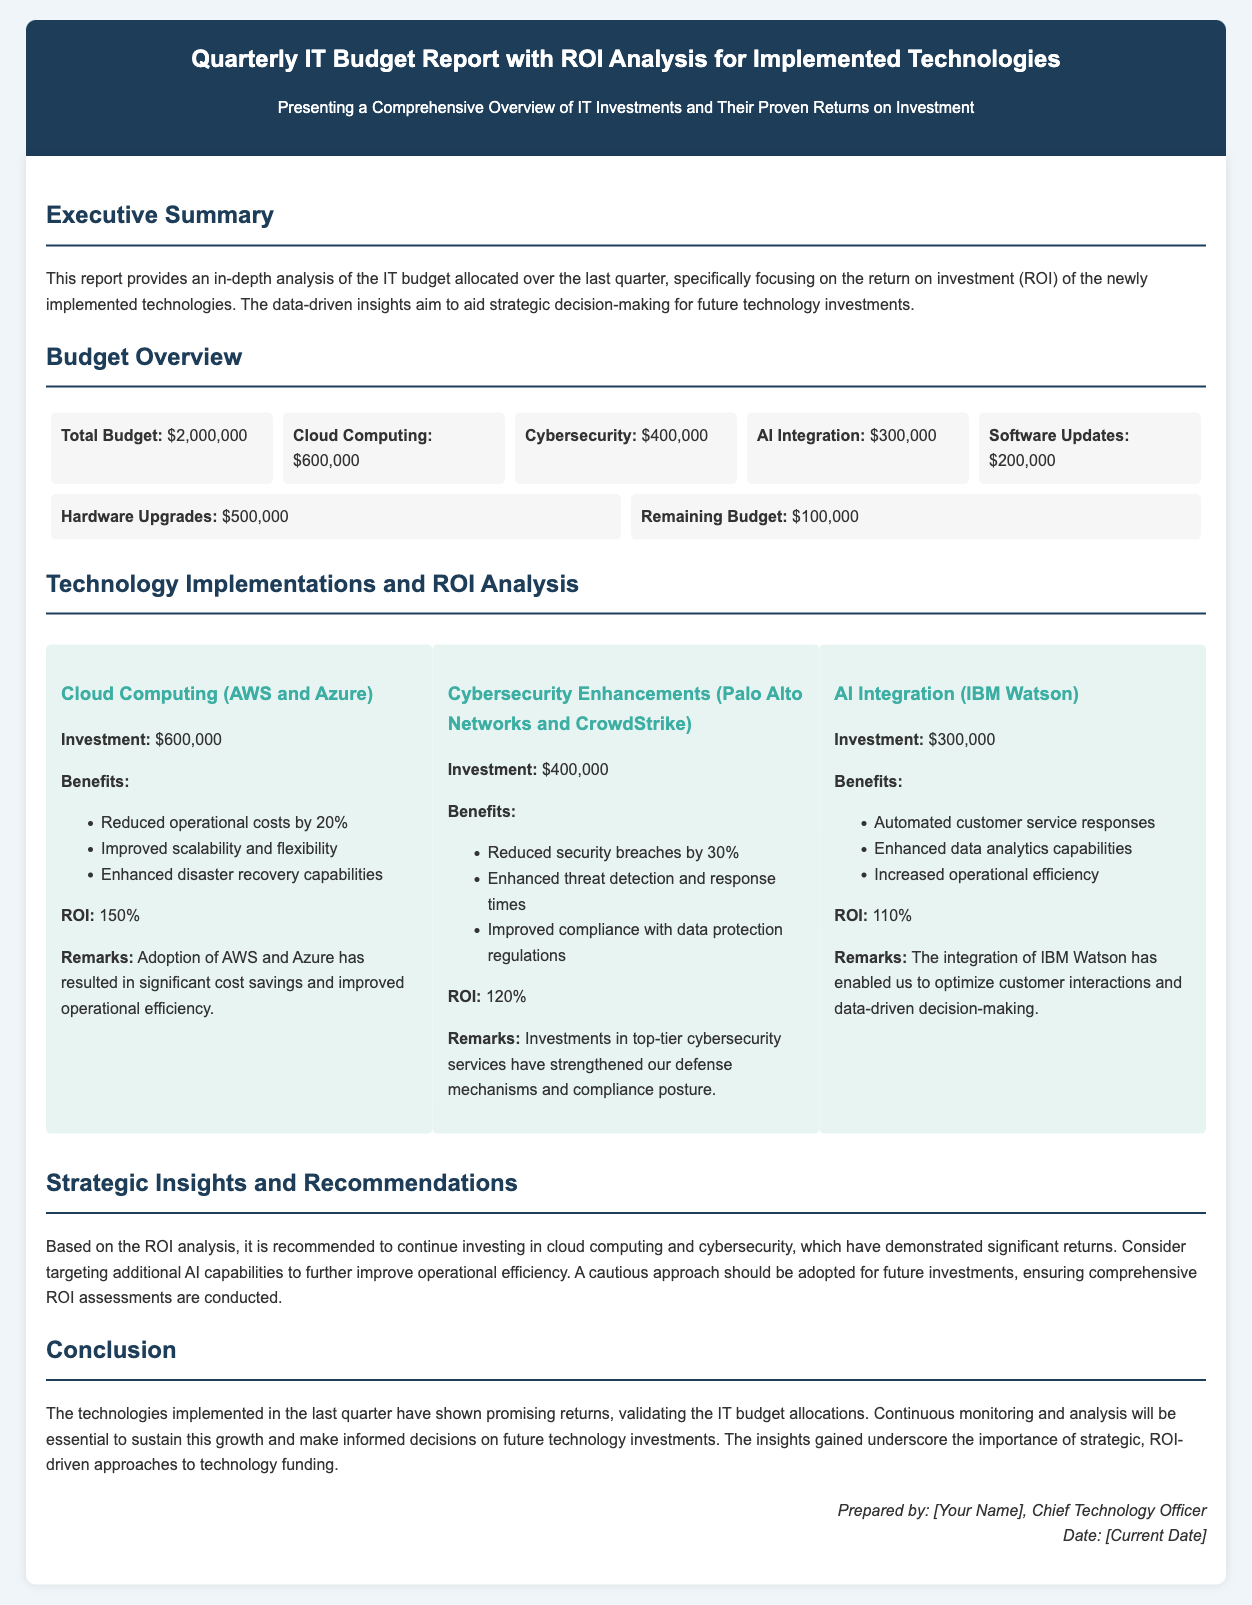what is the total budget? The total budget is the overall amount allocated for IT investments in the last quarter as shown in the budget overview section.
Answer: $2,000,000 what is the investment amount for Cybersecurity Enhancements? This investment amount reflects the budget allocated specifically to Cybersecurity Enhancements as detailed in the ROI analysis section.
Answer: $400,000 what is the ROI percentage for Cloud Computing? The ROI percentage indicates the financial return achieved from the Cloud Computing investment as stated in the technology implementations and ROI analysis.
Answer: 150% how much was allocated for AI Integration? This amount represents the budget specifically assigned for AI Integration technology as outlined in the budget overview.
Answer: $300,000 which technology showed a 30% reduction in security breaches? This technology is highlighted in the ROI analysis section, specifically mentioning the benefits gained from the investment.
Answer: Cybersecurity Enhancements what is the main recommendation based on the ROI analysis? The recommendation is drawn from the summary of insights regarding the performance of the technologies and advising on future investments.
Answer: Continue investing in cloud computing and cybersecurity who prepared the report? This refers to the individual responsible for compiling the report as noted in the footer of the document.
Answer: [Your Name] what are the total benefits listed under AI Integration? These benefits encompass the positive impacts observed from implementing AI technology as mentioned in the ROI analysis section.
Answer: Automated customer service responses, Enhanced data analytics capabilities, Increased operational efficiency what is the remaining budget after allocations? This figure indicates the leftover amount from the total budget after all investments have been made, as presented in the budget overview.
Answer: $100,000 